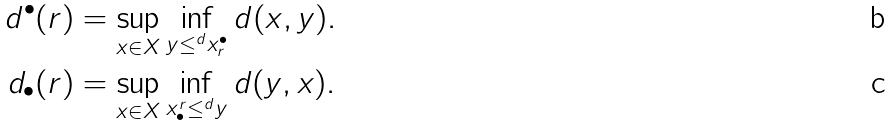<formula> <loc_0><loc_0><loc_500><loc_500>d ^ { \bullet } ( r ) & = \sup _ { x \in X } \inf _ { y \leq ^ { d } x ^ { \bullet } _ { r } } d ( x , y ) . \\ d _ { \bullet } ( r ) & = \sup _ { x \in X } \inf _ { x _ { \bullet } ^ { r } \leq ^ { d } y } d ( y , x ) .</formula> 